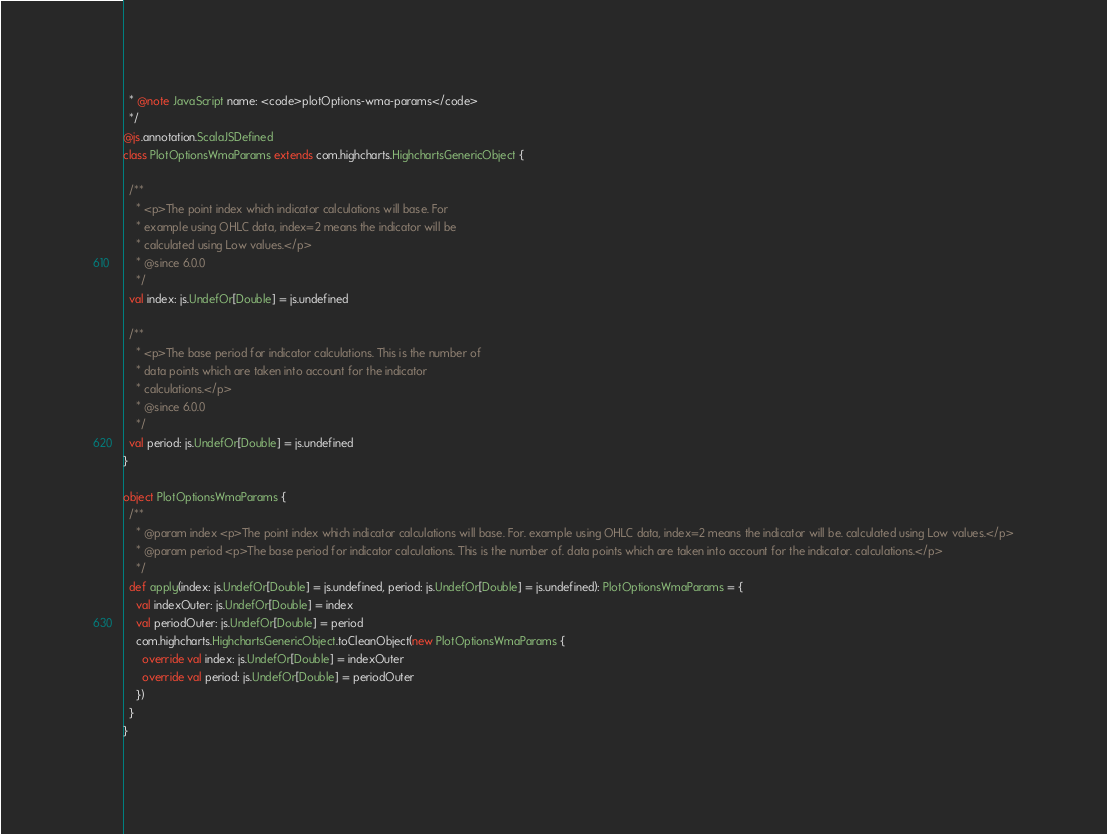<code> <loc_0><loc_0><loc_500><loc_500><_Scala_>  * @note JavaScript name: <code>plotOptions-wma-params</code>
  */
@js.annotation.ScalaJSDefined
class PlotOptionsWmaParams extends com.highcharts.HighchartsGenericObject {

  /**
    * <p>The point index which indicator calculations will base. For
    * example using OHLC data, index=2 means the indicator will be
    * calculated using Low values.</p>
    * @since 6.0.0
    */
  val index: js.UndefOr[Double] = js.undefined

  /**
    * <p>The base period for indicator calculations. This is the number of
    * data points which are taken into account for the indicator
    * calculations.</p>
    * @since 6.0.0
    */
  val period: js.UndefOr[Double] = js.undefined
}

object PlotOptionsWmaParams {
  /**
    * @param index <p>The point index which indicator calculations will base. For. example using OHLC data, index=2 means the indicator will be. calculated using Low values.</p>
    * @param period <p>The base period for indicator calculations. This is the number of. data points which are taken into account for the indicator. calculations.</p>
    */
  def apply(index: js.UndefOr[Double] = js.undefined, period: js.UndefOr[Double] = js.undefined): PlotOptionsWmaParams = {
    val indexOuter: js.UndefOr[Double] = index
    val periodOuter: js.UndefOr[Double] = period
    com.highcharts.HighchartsGenericObject.toCleanObject(new PlotOptionsWmaParams {
      override val index: js.UndefOr[Double] = indexOuter
      override val period: js.UndefOr[Double] = periodOuter
    })
  }
}
</code> 